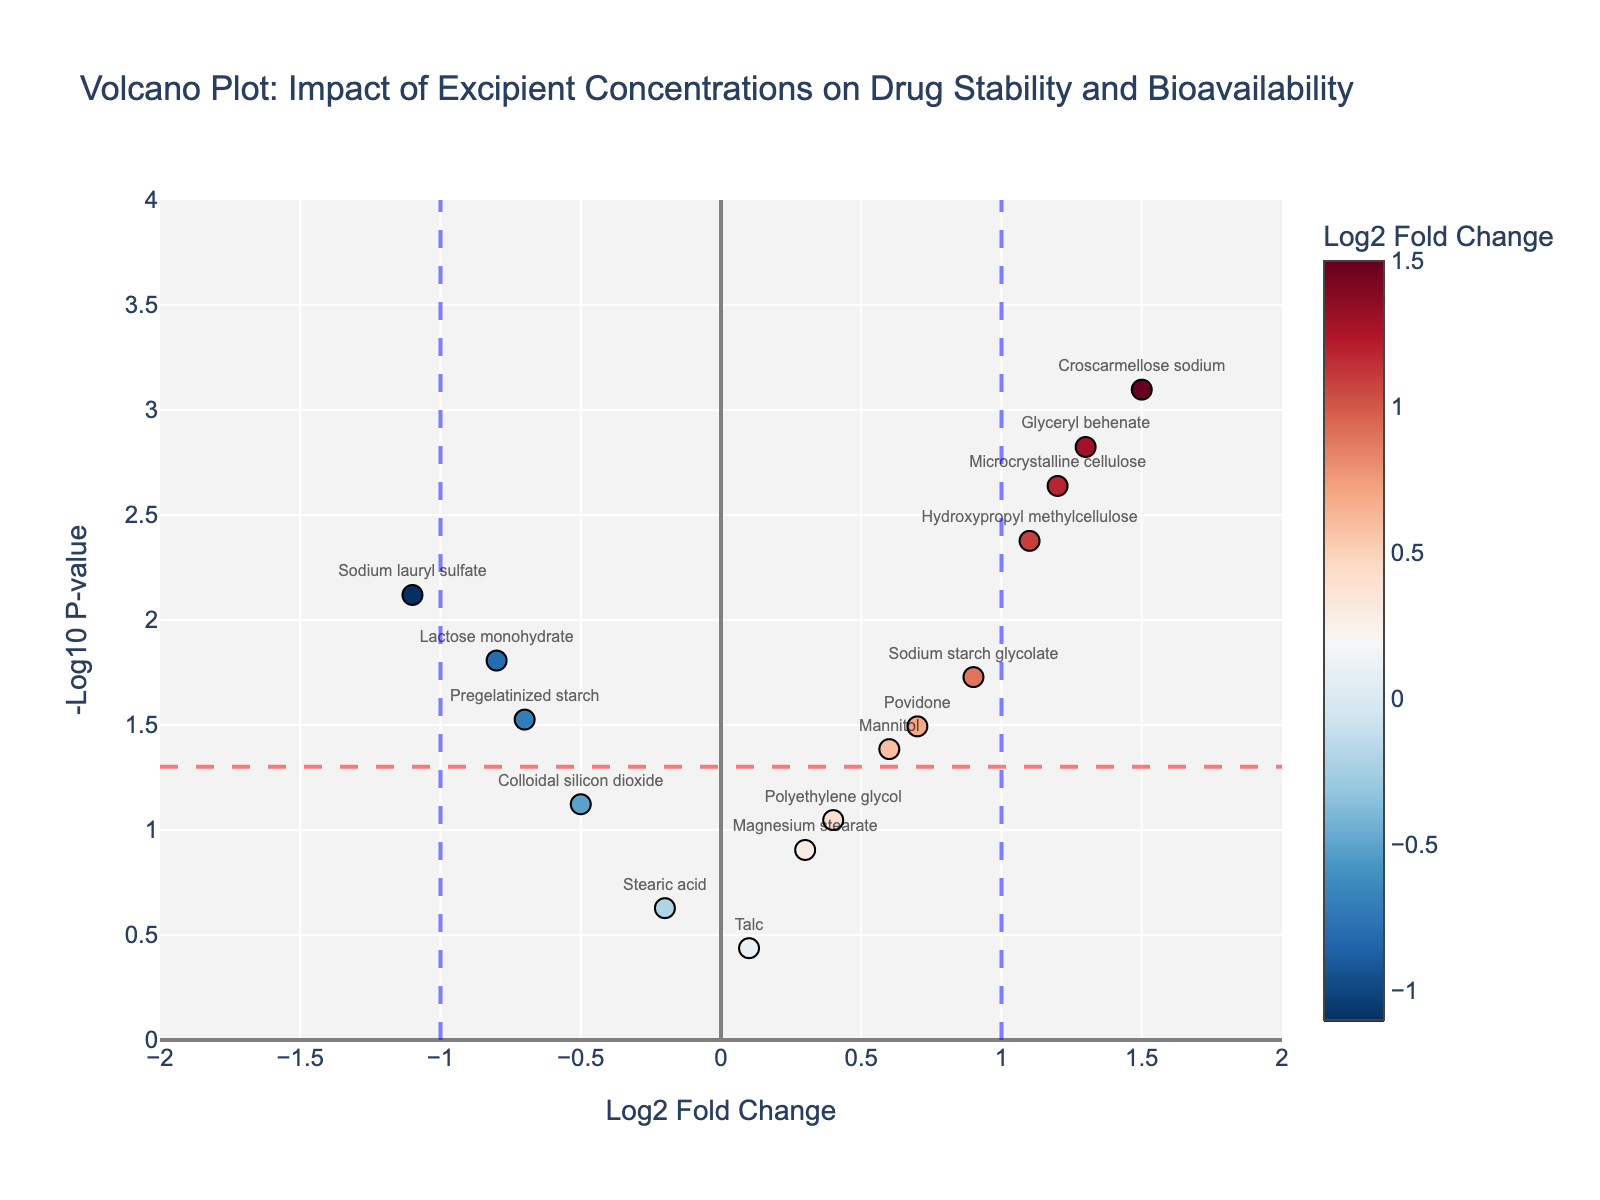Which excipient has the highest log2 fold change? Look at the x-axis values (Log2 Fold Change) and find the data point farthest to the right.
Answer: Croscarmellose sodium What is the p-value threshold line shown in the plot? The p-value threshold line is represented on the y-axis as the horizontal line. It is at -log10(0.05).
Answer: 0.05 How many excipients have a significant effect on drug stability and bioavailability? Count the number of data points that lie above the p-value threshold line (horizontal line at -log10(0.05)).
Answer: 8 Which excipients have a log2 fold change greater than 1 and a p-value less than 0.05? Locate excipients to the right of the vertical line at log2 fold change = 1 that are also above the horizontal line at -log10(0.05).
Answer: Microcrystalline cellulose, Croscarmellose sodium, Glyceryl behenate Which excipient has the lowest log2 fold change? Look at the x-axis values (Log2 Fold Change) and find the data point farthest to the left.
Answer: Sodium lauryl sulfate Which excipient, between Povidone and Mannitol, has a lower p-value? Compare the y-axis values (-log10 P-value) of Povidone and Mannitol to see which is higher (indicating a lower p-value).
Answer: Povidone How many excipients have a log2 fold change between -0.5 and 0.5? Count the data points with x-axis values (Log2 Fold Change) within the range -0.5 to 0.5.
Answer: 3 Which excipient has a p-value closest to 0.01? Identify the data point closest to the y-axis value corresponding to -log10(0.01).
Answer: Hydroxypropyl methylcellulose What is the log2 fold change of Lactose monohydrate? Locate the data point labeled "Lactose monohydrate" and read off the x-axis value.
Answer: -0.8 Which excipient closest to the p-value threshold line has a positive log2 fold change? Identify the data point with a log2 fold change > 0 and closest to the horizontal line at -log10(0.05).
Answer: Mannitol 